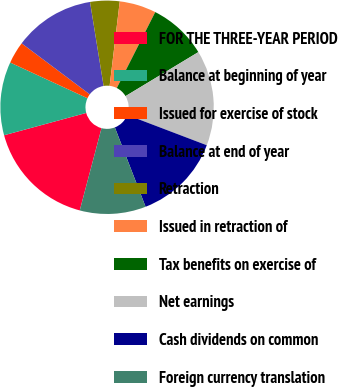<chart> <loc_0><loc_0><loc_500><loc_500><pie_chart><fcel>FOR THE THREE-YEAR PERIOD<fcel>Balance at beginning of year<fcel>Issued for exercise of stock<fcel>Balance at end of year<fcel>Retraction<fcel>Issued in retraction of<fcel>Tax benefits on exercise of<fcel>Net earnings<fcel>Cash dividends on common<fcel>Foreign currency translation<nl><fcel>16.66%<fcel>11.11%<fcel>3.34%<fcel>12.22%<fcel>4.45%<fcel>5.56%<fcel>8.89%<fcel>14.44%<fcel>13.33%<fcel>10.0%<nl></chart> 